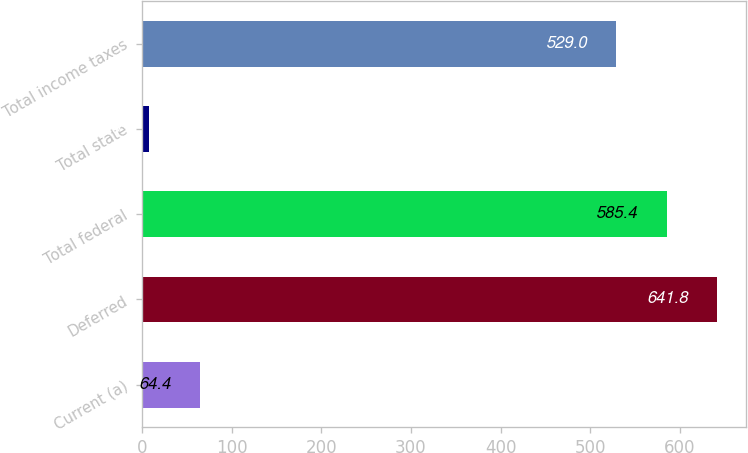<chart> <loc_0><loc_0><loc_500><loc_500><bar_chart><fcel>Current (a)<fcel>Deferred<fcel>Total federal<fcel>Total state<fcel>Total income taxes<nl><fcel>64.4<fcel>641.8<fcel>585.4<fcel>8<fcel>529<nl></chart> 